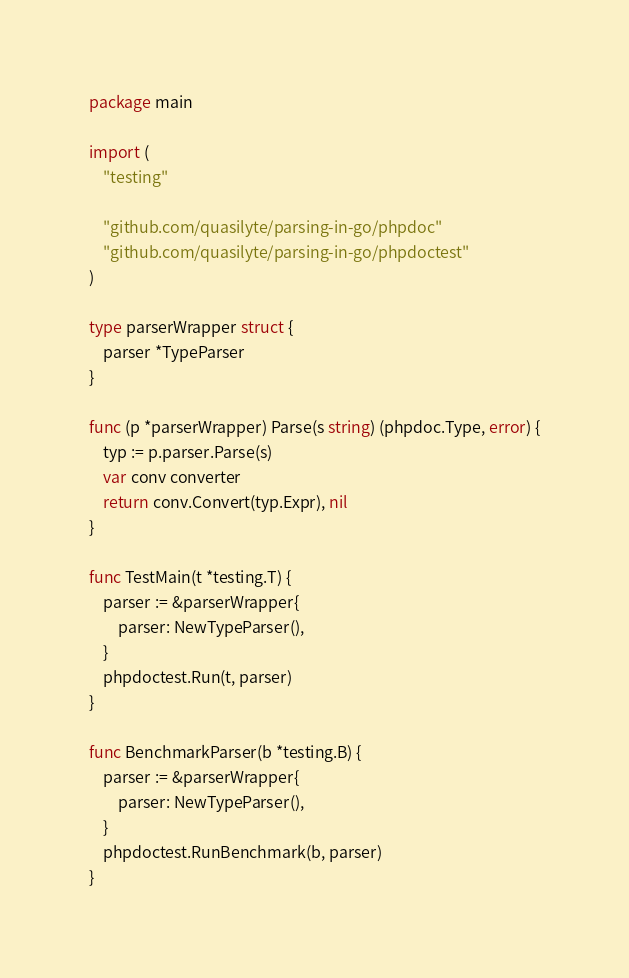Convert code to text. <code><loc_0><loc_0><loc_500><loc_500><_Go_>package main

import (
	"testing"

	"github.com/quasilyte/parsing-in-go/phpdoc"
	"github.com/quasilyte/parsing-in-go/phpdoctest"
)

type parserWrapper struct {
	parser *TypeParser
}

func (p *parserWrapper) Parse(s string) (phpdoc.Type, error) {
	typ := p.parser.Parse(s)
	var conv converter
	return conv.Convert(typ.Expr), nil
}

func TestMain(t *testing.T) {
	parser := &parserWrapper{
		parser: NewTypeParser(),
	}
	phpdoctest.Run(t, parser)
}

func BenchmarkParser(b *testing.B) {
	parser := &parserWrapper{
		parser: NewTypeParser(),
	}
	phpdoctest.RunBenchmark(b, parser)
}
</code> 